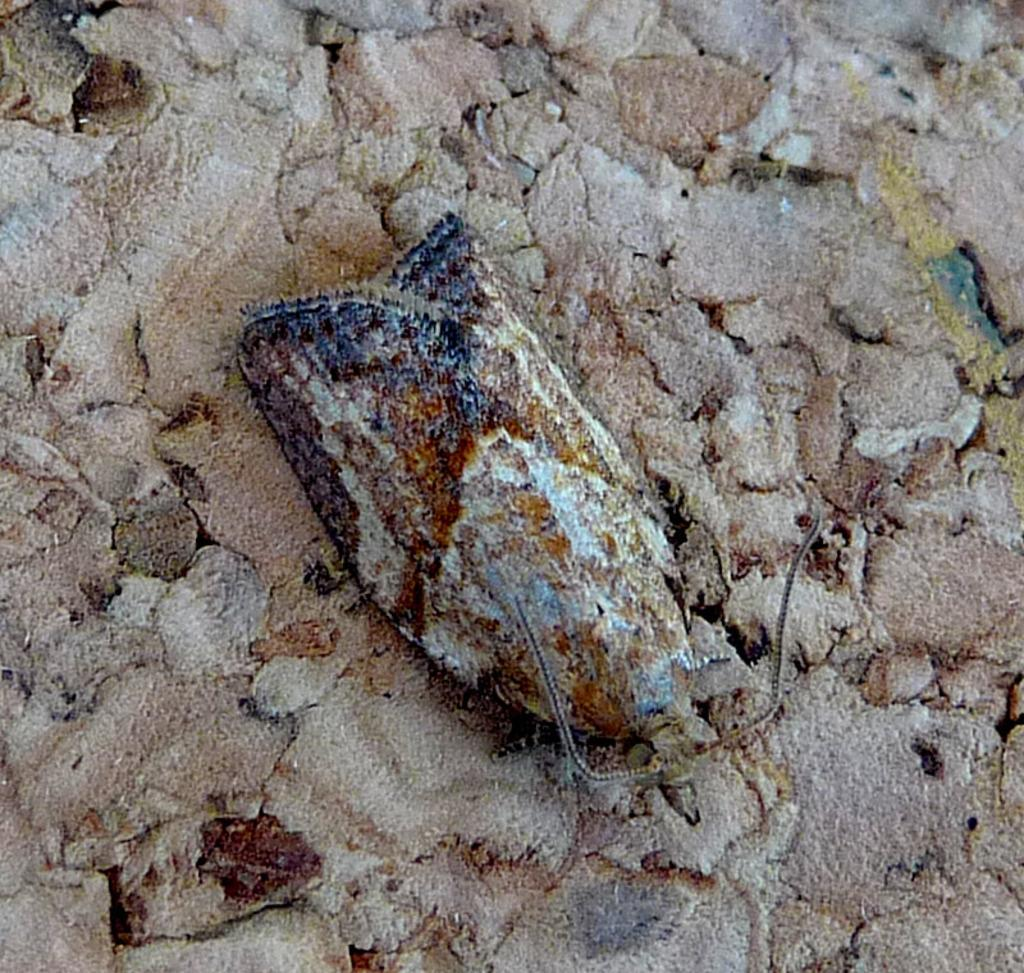What type of creature can be seen in the image? There is an insect in the image. Where is the insect located in the image? The insect is on the ground. How many cows are present in the image? There are no cows present in the image; it features an insect on the ground. What type of board can be seen in the image? There is no board present in the image. 